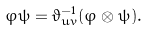Convert formula to latex. <formula><loc_0><loc_0><loc_500><loc_500>\varphi \psi = \vartheta _ { u v } ^ { - 1 } ( \varphi \otimes \psi ) .</formula> 